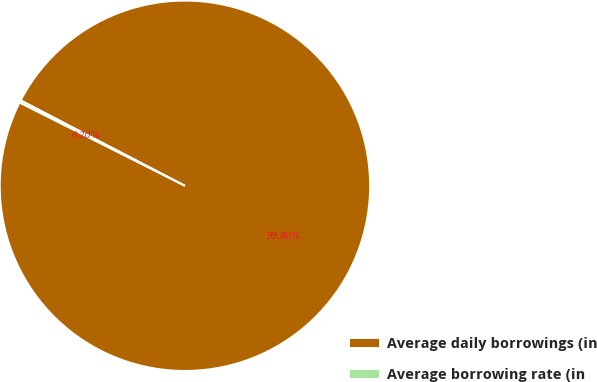<chart> <loc_0><loc_0><loc_500><loc_500><pie_chart><fcel>Average daily borrowings (in<fcel>Average borrowing rate (in<nl><fcel>99.8%<fcel>0.2%<nl></chart> 